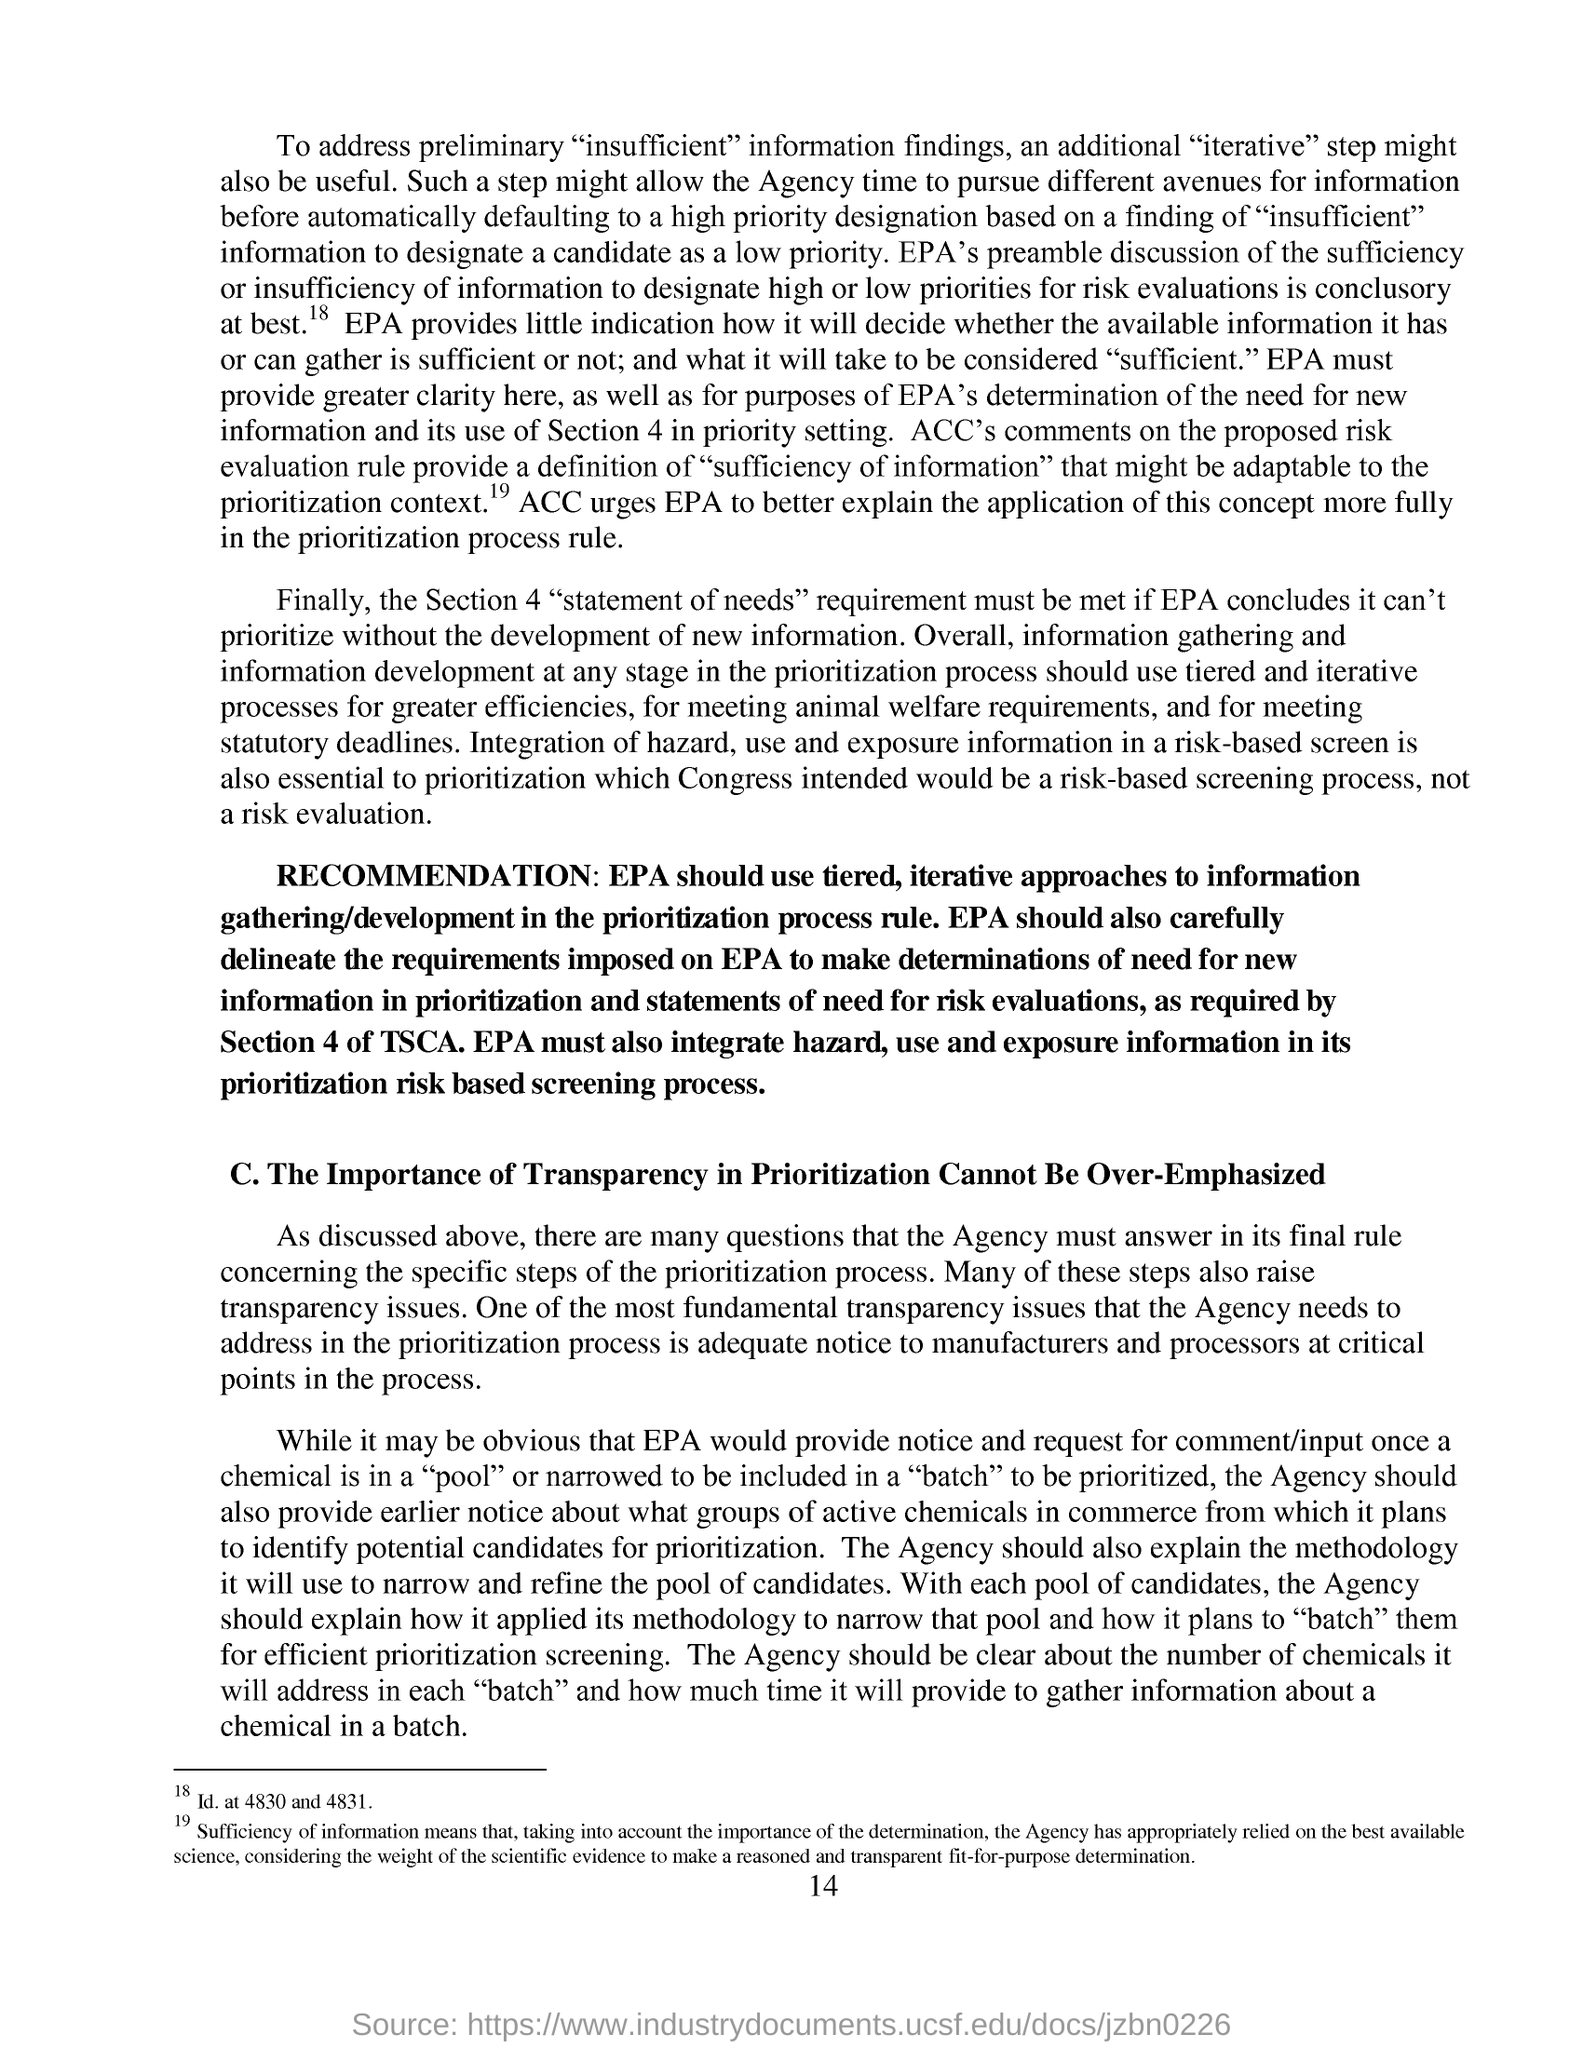Highlight a few significant elements in this photo. The page number mentioned in this document is 14. It is essential for the agency to address the fundamental transparency issue of providing adequate notice to manufacturers and processors at critical points in the prioritization process. 